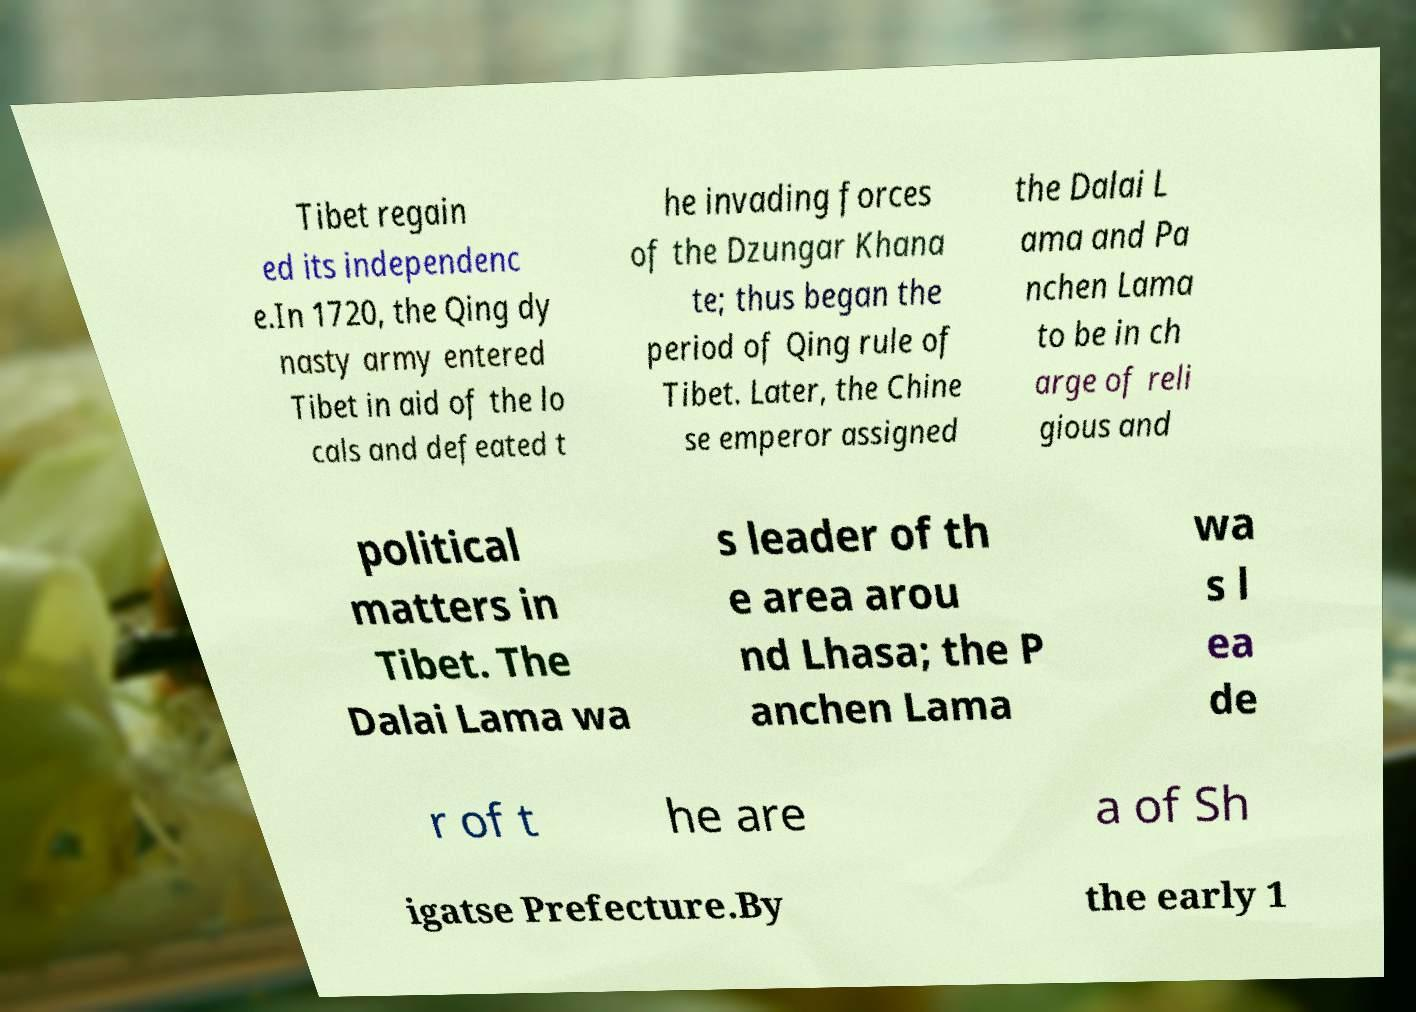I need the written content from this picture converted into text. Can you do that? Tibet regain ed its independenc e.In 1720, the Qing dy nasty army entered Tibet in aid of the lo cals and defeated t he invading forces of the Dzungar Khana te; thus began the period of Qing rule of Tibet. Later, the Chine se emperor assigned the Dalai L ama and Pa nchen Lama to be in ch arge of reli gious and political matters in Tibet. The Dalai Lama wa s leader of th e area arou nd Lhasa; the P anchen Lama wa s l ea de r of t he are a of Sh igatse Prefecture.By the early 1 